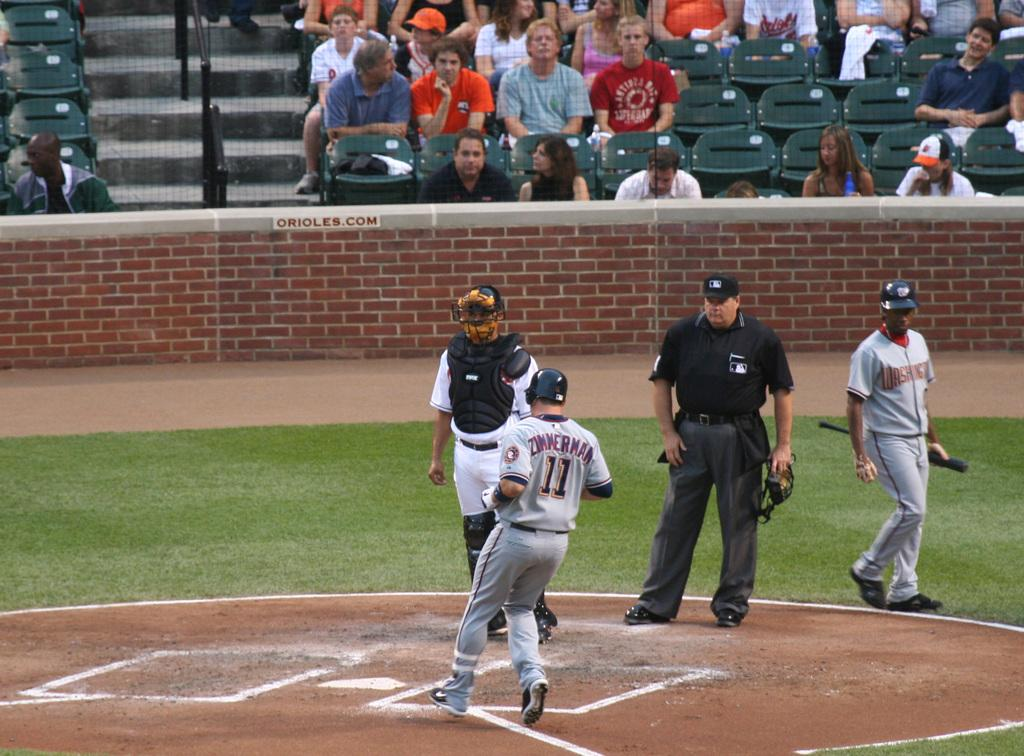<image>
Relay a brief, clear account of the picture shown. baseball player number 11 with a jersey that says 'zimmerman' on it 